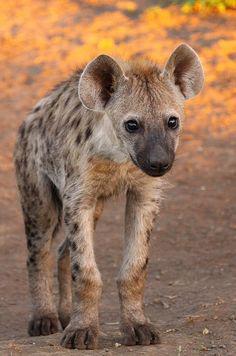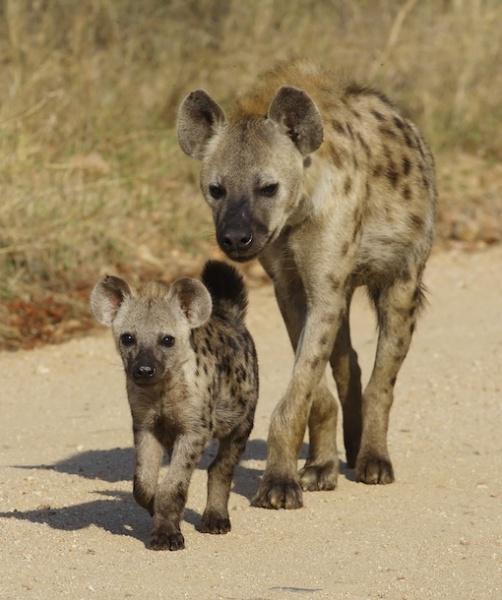The first image is the image on the left, the second image is the image on the right. Evaluate the accuracy of this statement regarding the images: "The animal in the image on the left is facing the camera". Is it true? Answer yes or no. Yes. 